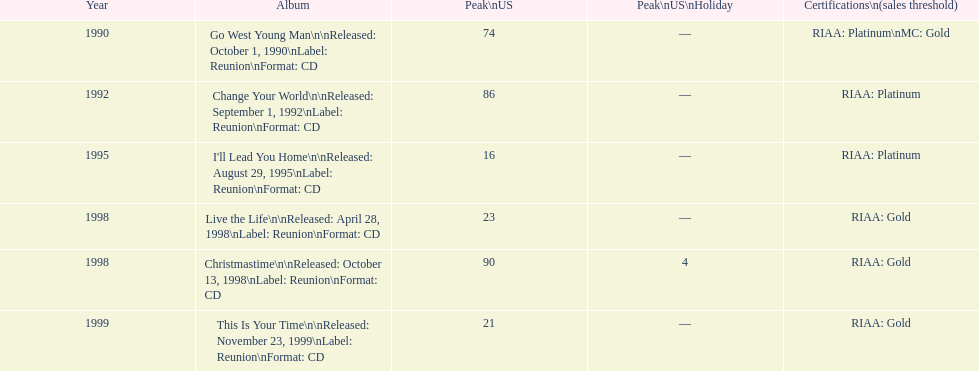What michael w. smith album came out before his christmastime album? Live the Life. 